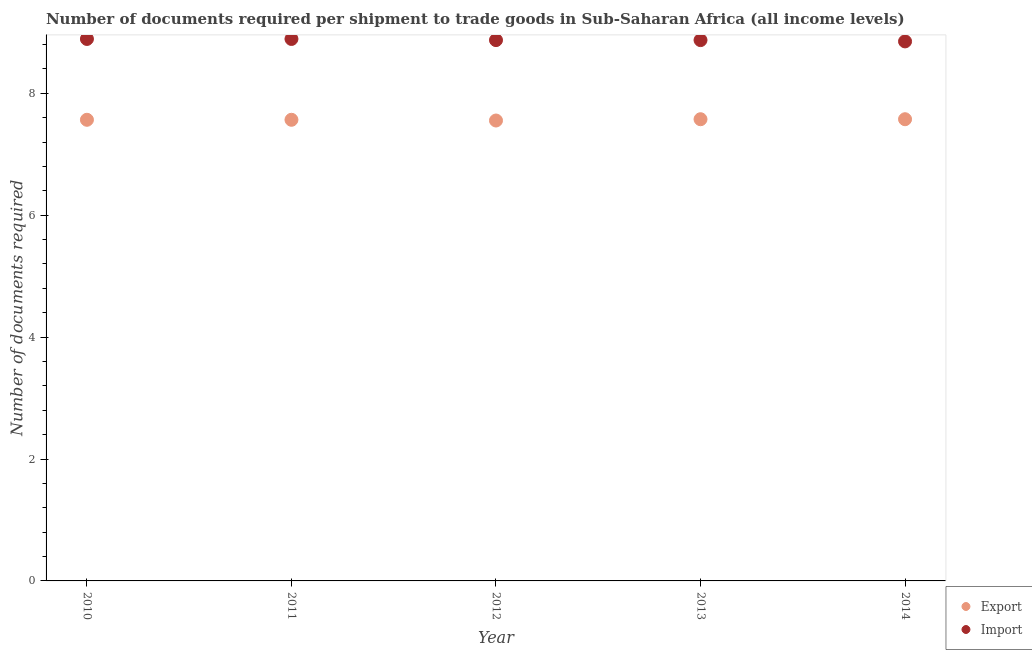Is the number of dotlines equal to the number of legend labels?
Your answer should be compact. Yes. What is the number of documents required to export goods in 2011?
Provide a succinct answer. 7.57. Across all years, what is the maximum number of documents required to import goods?
Your answer should be compact. 8.89. Across all years, what is the minimum number of documents required to export goods?
Your answer should be compact. 7.55. In which year was the number of documents required to export goods maximum?
Your answer should be compact. 2013. What is the total number of documents required to export goods in the graph?
Provide a succinct answer. 37.83. What is the difference between the number of documents required to import goods in 2010 and that in 2011?
Offer a terse response. 0. What is the difference between the number of documents required to export goods in 2011 and the number of documents required to import goods in 2013?
Your answer should be compact. -1.31. What is the average number of documents required to export goods per year?
Ensure brevity in your answer.  7.57. In the year 2014, what is the difference between the number of documents required to import goods and number of documents required to export goods?
Your answer should be compact. 1.28. In how many years, is the number of documents required to export goods greater than 2.8?
Give a very brief answer. 5. What is the ratio of the number of documents required to export goods in 2011 to that in 2012?
Your response must be concise. 1. Is the number of documents required to export goods in 2010 less than that in 2014?
Make the answer very short. Yes. What is the difference between the highest and the lowest number of documents required to export goods?
Offer a very short reply. 0.02. In how many years, is the number of documents required to import goods greater than the average number of documents required to import goods taken over all years?
Provide a short and direct response. 2. Is the sum of the number of documents required to export goods in 2010 and 2013 greater than the maximum number of documents required to import goods across all years?
Your answer should be very brief. Yes. Does the number of documents required to export goods monotonically increase over the years?
Your response must be concise. No. Is the number of documents required to import goods strictly greater than the number of documents required to export goods over the years?
Provide a succinct answer. Yes. How many dotlines are there?
Your answer should be compact. 2. What is the difference between two consecutive major ticks on the Y-axis?
Ensure brevity in your answer.  2. Does the graph contain grids?
Ensure brevity in your answer.  No. How many legend labels are there?
Give a very brief answer. 2. What is the title of the graph?
Keep it short and to the point. Number of documents required per shipment to trade goods in Sub-Saharan Africa (all income levels). What is the label or title of the X-axis?
Your answer should be very brief. Year. What is the label or title of the Y-axis?
Offer a terse response. Number of documents required. What is the Number of documents required in Export in 2010?
Provide a short and direct response. 7.57. What is the Number of documents required of Import in 2010?
Keep it short and to the point. 8.89. What is the Number of documents required in Export in 2011?
Your answer should be very brief. 7.57. What is the Number of documents required of Import in 2011?
Provide a succinct answer. 8.89. What is the Number of documents required of Export in 2012?
Make the answer very short. 7.55. What is the Number of documents required in Import in 2012?
Give a very brief answer. 8.87. What is the Number of documents required in Export in 2013?
Offer a very short reply. 7.57. What is the Number of documents required of Import in 2013?
Your response must be concise. 8.87. What is the Number of documents required of Export in 2014?
Give a very brief answer. 7.57. What is the Number of documents required in Import in 2014?
Provide a succinct answer. 8.85. Across all years, what is the maximum Number of documents required of Export?
Offer a terse response. 7.57. Across all years, what is the maximum Number of documents required in Import?
Give a very brief answer. 8.89. Across all years, what is the minimum Number of documents required of Export?
Your answer should be very brief. 7.55. Across all years, what is the minimum Number of documents required in Import?
Ensure brevity in your answer.  8.85. What is the total Number of documents required of Export in the graph?
Provide a short and direct response. 37.83. What is the total Number of documents required in Import in the graph?
Provide a succinct answer. 44.38. What is the difference between the Number of documents required of Export in 2010 and that in 2011?
Offer a very short reply. 0. What is the difference between the Number of documents required of Export in 2010 and that in 2012?
Provide a short and direct response. 0.01. What is the difference between the Number of documents required of Import in 2010 and that in 2012?
Make the answer very short. 0.02. What is the difference between the Number of documents required of Export in 2010 and that in 2013?
Keep it short and to the point. -0.01. What is the difference between the Number of documents required in Import in 2010 and that in 2013?
Offer a very short reply. 0.02. What is the difference between the Number of documents required of Export in 2010 and that in 2014?
Your answer should be very brief. -0.01. What is the difference between the Number of documents required of Import in 2010 and that in 2014?
Keep it short and to the point. 0.04. What is the difference between the Number of documents required in Export in 2011 and that in 2012?
Keep it short and to the point. 0.01. What is the difference between the Number of documents required of Import in 2011 and that in 2012?
Make the answer very short. 0.02. What is the difference between the Number of documents required of Export in 2011 and that in 2013?
Your answer should be very brief. -0.01. What is the difference between the Number of documents required of Import in 2011 and that in 2013?
Your answer should be very brief. 0.02. What is the difference between the Number of documents required in Export in 2011 and that in 2014?
Your answer should be very brief. -0.01. What is the difference between the Number of documents required of Import in 2011 and that in 2014?
Your answer should be very brief. 0.04. What is the difference between the Number of documents required in Export in 2012 and that in 2013?
Your response must be concise. -0.02. What is the difference between the Number of documents required of Import in 2012 and that in 2013?
Your response must be concise. 0. What is the difference between the Number of documents required of Export in 2012 and that in 2014?
Keep it short and to the point. -0.02. What is the difference between the Number of documents required of Import in 2012 and that in 2014?
Give a very brief answer. 0.02. What is the difference between the Number of documents required in Export in 2013 and that in 2014?
Your answer should be compact. 0. What is the difference between the Number of documents required of Import in 2013 and that in 2014?
Your response must be concise. 0.02. What is the difference between the Number of documents required in Export in 2010 and the Number of documents required in Import in 2011?
Your response must be concise. -1.33. What is the difference between the Number of documents required of Export in 2010 and the Number of documents required of Import in 2012?
Offer a very short reply. -1.31. What is the difference between the Number of documents required in Export in 2010 and the Number of documents required in Import in 2013?
Offer a terse response. -1.31. What is the difference between the Number of documents required of Export in 2010 and the Number of documents required of Import in 2014?
Offer a very short reply. -1.29. What is the difference between the Number of documents required in Export in 2011 and the Number of documents required in Import in 2012?
Your response must be concise. -1.31. What is the difference between the Number of documents required in Export in 2011 and the Number of documents required in Import in 2013?
Provide a short and direct response. -1.31. What is the difference between the Number of documents required of Export in 2011 and the Number of documents required of Import in 2014?
Make the answer very short. -1.29. What is the difference between the Number of documents required in Export in 2012 and the Number of documents required in Import in 2013?
Your response must be concise. -1.32. What is the difference between the Number of documents required of Export in 2012 and the Number of documents required of Import in 2014?
Keep it short and to the point. -1.3. What is the difference between the Number of documents required in Export in 2013 and the Number of documents required in Import in 2014?
Your response must be concise. -1.28. What is the average Number of documents required of Export per year?
Keep it short and to the point. 7.57. What is the average Number of documents required of Import per year?
Keep it short and to the point. 8.88. In the year 2010, what is the difference between the Number of documents required in Export and Number of documents required in Import?
Your response must be concise. -1.33. In the year 2011, what is the difference between the Number of documents required in Export and Number of documents required in Import?
Ensure brevity in your answer.  -1.33. In the year 2012, what is the difference between the Number of documents required in Export and Number of documents required in Import?
Your answer should be very brief. -1.32. In the year 2013, what is the difference between the Number of documents required of Export and Number of documents required of Import?
Offer a very short reply. -1.3. In the year 2014, what is the difference between the Number of documents required in Export and Number of documents required in Import?
Your answer should be compact. -1.28. What is the ratio of the Number of documents required of Import in 2010 to that in 2012?
Give a very brief answer. 1. What is the ratio of the Number of documents required in Export in 2010 to that in 2013?
Offer a terse response. 1. What is the ratio of the Number of documents required of Export in 2011 to that in 2012?
Provide a succinct answer. 1. What is the ratio of the Number of documents required in Export in 2012 to that in 2013?
Your response must be concise. 1. What is the difference between the highest and the second highest Number of documents required of Export?
Keep it short and to the point. 0. What is the difference between the highest and the lowest Number of documents required in Export?
Offer a terse response. 0.02. What is the difference between the highest and the lowest Number of documents required of Import?
Ensure brevity in your answer.  0.04. 